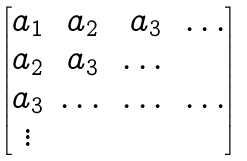<formula> <loc_0><loc_0><loc_500><loc_500>\begin{bmatrix} a _ { 1 } & a _ { 2 } & a _ { 3 } & \dots \\ a _ { 2 } & a _ { 3 } & \dots & \\ a _ { 3 } & \dots & \dots & \dots \\ \vdots & & & \end{bmatrix}</formula> 